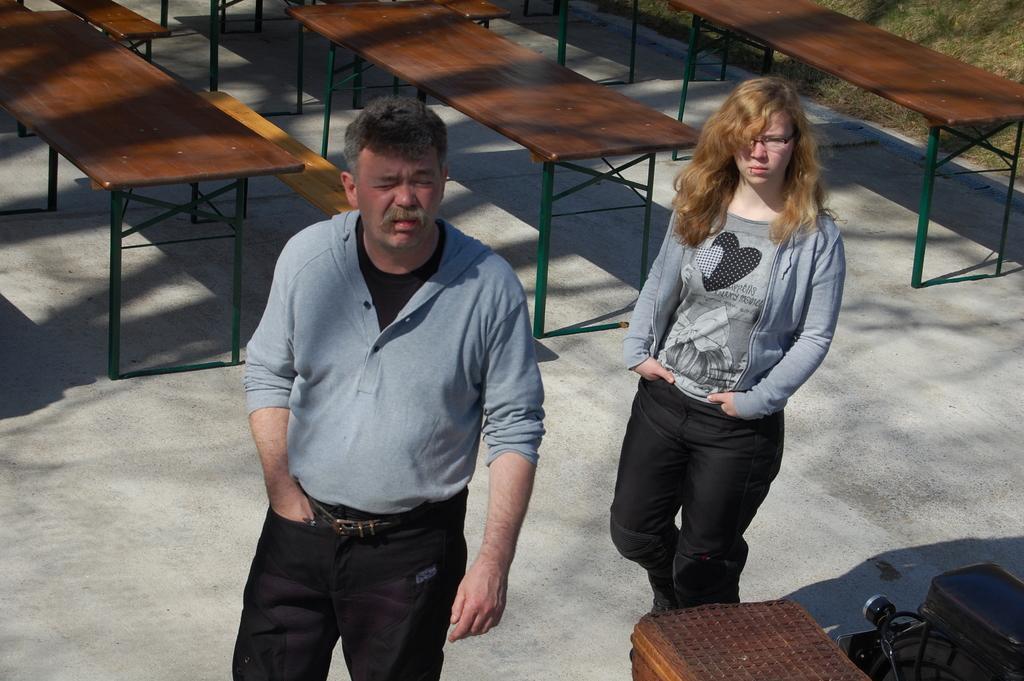Can you describe this image briefly? In this image, we can see two peoples are standing. Women wear a ash color t shirt and jacket, pant. The left side, men wear a jacket, black color t shirt, pant, belt. Here we can see few some benches at back side. At the right side corner, we can see grass. The bottom, we can see few wires and bag and box. 